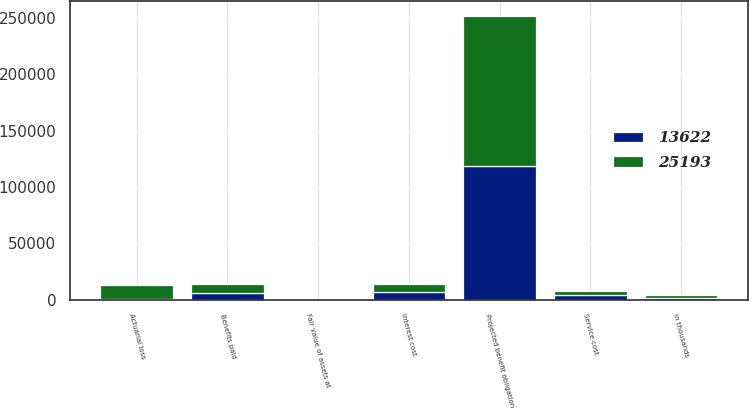Convert chart to OTSL. <chart><loc_0><loc_0><loc_500><loc_500><stacked_bar_chart><ecel><fcel>in thousands<fcel>Projected benefit obligation<fcel>Service cost<fcel>Interest cost<fcel>Actuarial loss<fcel>Benefits paid<fcel>Fair value of assets at<nl><fcel>25193<fcel>2010<fcel>133717<fcel>4265<fcel>6651<fcel>11730<fcel>7242<fcel>0<nl><fcel>13622<fcel>2009<fcel>118313<fcel>3912<fcel>7045<fcel>974<fcel>6455<fcel>0<nl></chart> 